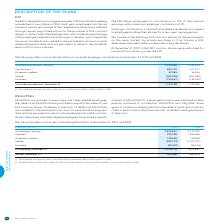According to Bce's financial document, What was the number of  Unvested contributions, January 1 for 2019? According to the financial document, 1,120,426. The relevant text states: "Unvested contributions, January 1 1,120,426 1,039,030..." Also, What are the conditions regarding employer contributions to the ESP and related dividends? subject to employees holding their shares for a two-year vesting period. The document states: "ontributions to the ESP and related dividends are subject to employees holding their shares for a two-year vesting period...." Also, Who can contribute to the ESP? The document shows two values: employees and employer. From the document: "The ESP is designed to encourage employees of BCE and its participating subsidiaries to own shares of BCE. Each year, employees can choose to The ESP ..." Additionally, Which year had a larger amount of dividends credited? According to the financial document, 2019. The relevant text states: "NUMBER OF ESP SHARES 2019 2018..." Also, can you calculate: What is the percentage of unvested contributions on December 31 2019 out of the common shares authorized for issuance from treasury under the ESP? Based on the calculation: 1,124,198/4,360,087, the result is 25.78 (percentage). This is based on the information: "Unvested contributions, December 31 1,124,198 1,120,426 At December 31, 2019, 4,360,087 common shares were authorized for issuance from treasury under the ESP...." The key data points involved are: 1,124,198, 4,360,087. Also, can you calculate: What is the percentage change in Contributions in 2019? To answer this question, I need to perform calculations using the financial data. The calculation is: (623,705-671,911)/671,911, which equals -7.17 (percentage). This is based on the information: "Contributions (1) 623,705 671,911 Contributions (1) 623,705 671,911..." The key data points involved are: 623,705, 671,911. 